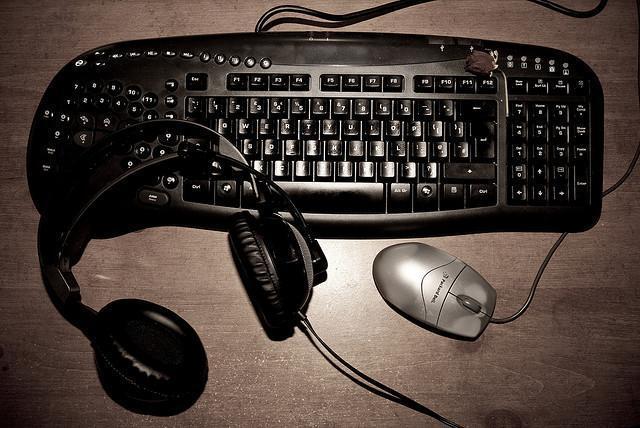How many people are wearing a black shirt?
Give a very brief answer. 0. 